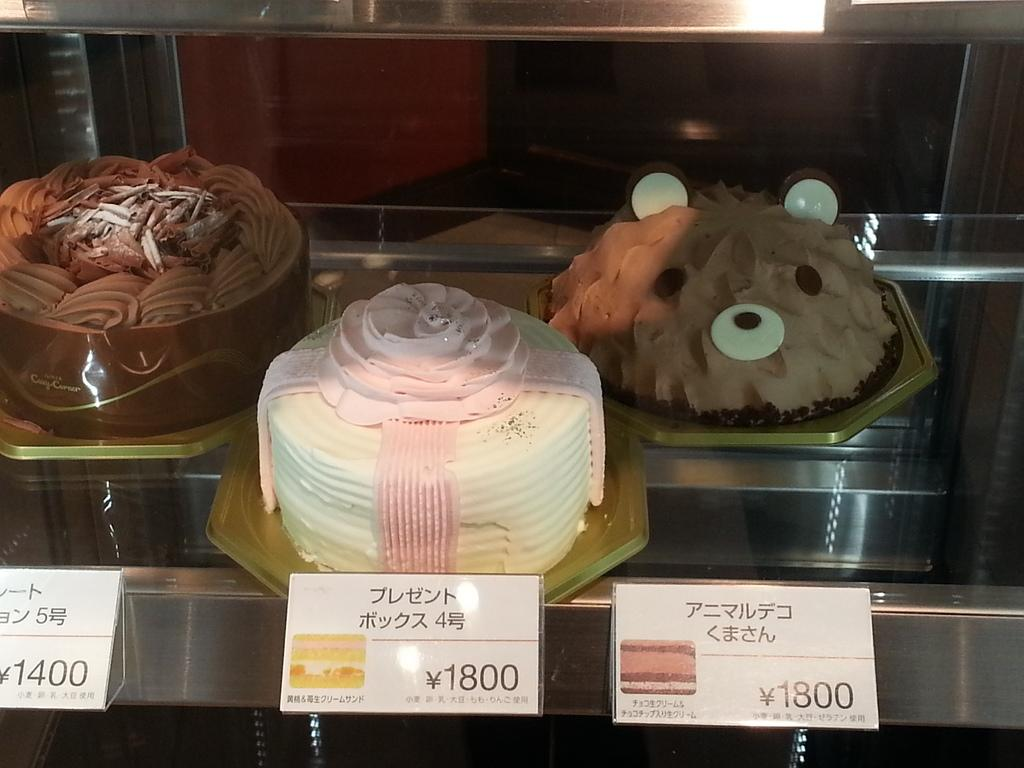What type of items can be seen in the image? There are price cards and three cakes on plates in the image. Where are the plates with cakes located? The plates with cakes are on a rack. What can be seen in the background of the image? There are objects visible in the background of the image. Can you see any ghosts interacting with the cakes in the image? There are no ghosts present in the image. What type of pets are visible in the image? There are no pets visible in the image. 